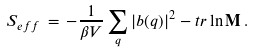Convert formula to latex. <formula><loc_0><loc_0><loc_500><loc_500>S _ { e f f } \, = \, - \frac { 1 } { \beta V } \sum _ { q } | b ( q ) | ^ { 2 } - t r \ln { \mathbf M } \, .</formula> 